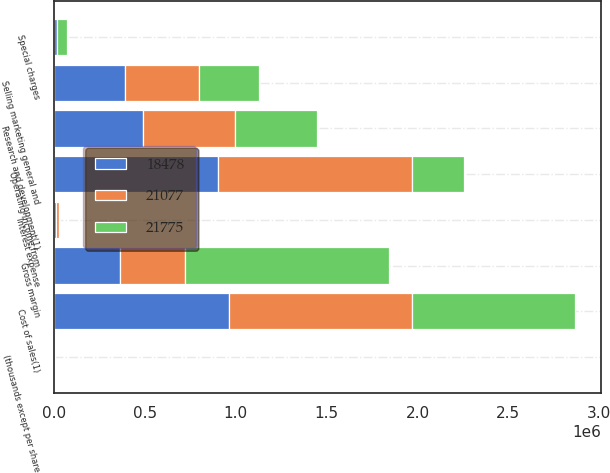Convert chart to OTSL. <chart><loc_0><loc_0><loc_500><loc_500><stacked_bar_chart><ecel><fcel>(thousands except per share<fcel>Cost of sales(1)<fcel>Gross margin<fcel>Research and development(1)<fcel>Selling marketing general and<fcel>Special charges<fcel>Operating income from<fcel>Interest expense<nl><fcel>21077<fcel>2011<fcel>1.00678e+06<fcel>361872<fcel>505570<fcel>406707<fcel>2239<fcel>1.07202e+06<fcel>19146<nl><fcel>18478<fcel>2010<fcel>962081<fcel>361872<fcel>492305<fcel>390560<fcel>16483<fcel>900074<fcel>10429<nl><fcel>21775<fcel>2009<fcel>896271<fcel>1.11864e+06<fcel>446980<fcel>333184<fcel>53656<fcel>284817<fcel>4094<nl></chart> 